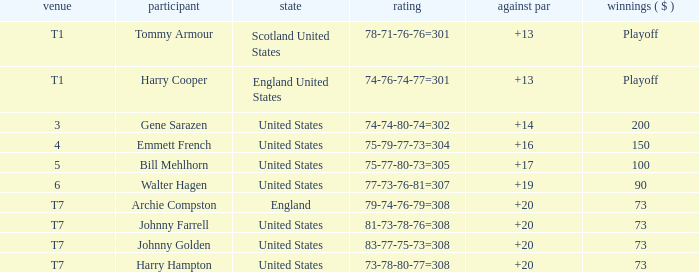Which country has a to par less than 19 and a score of 75-79-77-73=304? United States. 